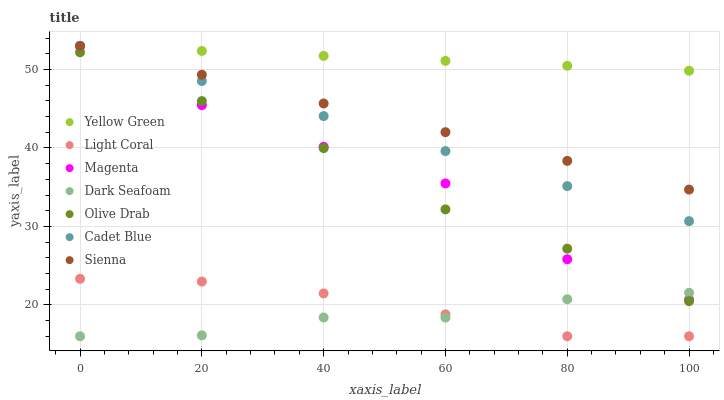Does Dark Seafoam have the minimum area under the curve?
Answer yes or no. Yes. Does Yellow Green have the maximum area under the curve?
Answer yes or no. Yes. Does Cadet Blue have the minimum area under the curve?
Answer yes or no. No. Does Cadet Blue have the maximum area under the curve?
Answer yes or no. No. Is Sienna the smoothest?
Answer yes or no. Yes. Is Magenta the roughest?
Answer yes or no. Yes. Is Yellow Green the smoothest?
Answer yes or no. No. Is Yellow Green the roughest?
Answer yes or no. No. Does Light Coral have the lowest value?
Answer yes or no. Yes. Does Cadet Blue have the lowest value?
Answer yes or no. No. Does Magenta have the highest value?
Answer yes or no. Yes. Does Light Coral have the highest value?
Answer yes or no. No. Is Olive Drab less than Cadet Blue?
Answer yes or no. Yes. Is Sienna greater than Light Coral?
Answer yes or no. Yes. Does Cadet Blue intersect Yellow Green?
Answer yes or no. Yes. Is Cadet Blue less than Yellow Green?
Answer yes or no. No. Is Cadet Blue greater than Yellow Green?
Answer yes or no. No. Does Olive Drab intersect Cadet Blue?
Answer yes or no. No. 